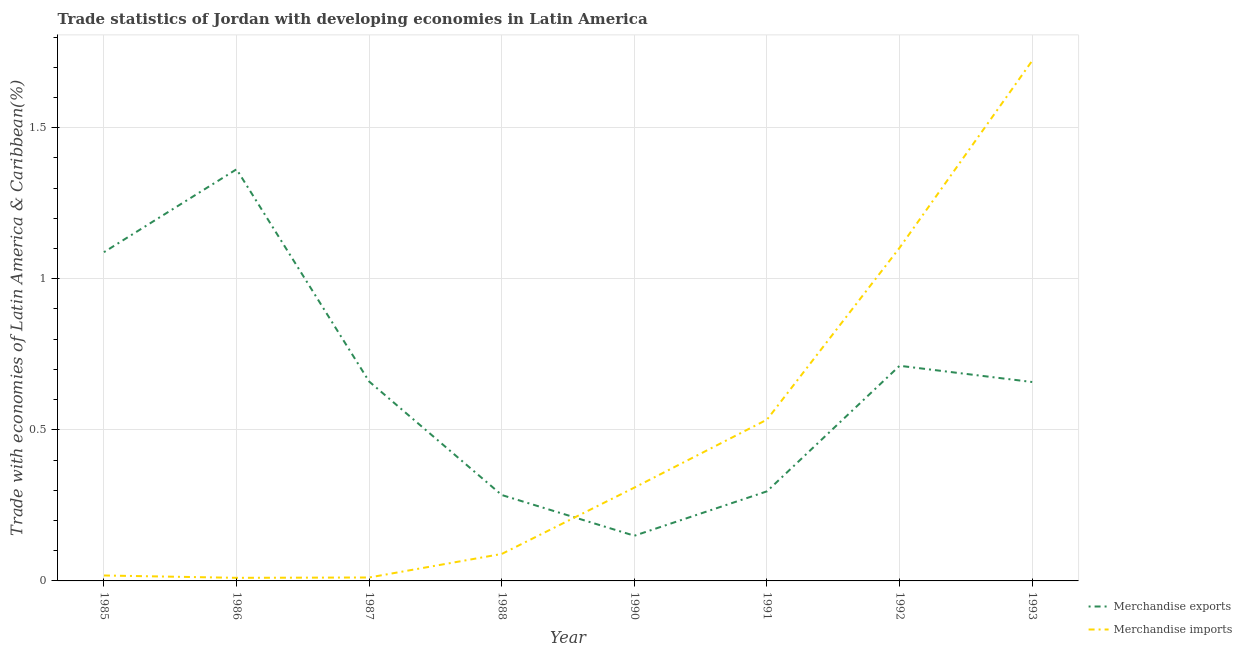How many different coloured lines are there?
Provide a succinct answer. 2. Is the number of lines equal to the number of legend labels?
Your response must be concise. Yes. What is the merchandise imports in 1986?
Your answer should be very brief. 0.01. Across all years, what is the maximum merchandise exports?
Offer a terse response. 1.36. Across all years, what is the minimum merchandise imports?
Your response must be concise. 0.01. In which year was the merchandise exports minimum?
Give a very brief answer. 1990. What is the total merchandise imports in the graph?
Offer a very short reply. 3.8. What is the difference between the merchandise imports in 1991 and that in 1992?
Give a very brief answer. -0.57. What is the difference between the merchandise exports in 1991 and the merchandise imports in 1988?
Give a very brief answer. 0.21. What is the average merchandise imports per year?
Ensure brevity in your answer.  0.47. In the year 1993, what is the difference between the merchandise exports and merchandise imports?
Offer a terse response. -1.06. In how many years, is the merchandise exports greater than 0.4 %?
Offer a terse response. 5. What is the ratio of the merchandise imports in 1987 to that in 1988?
Your answer should be very brief. 0.13. Is the merchandise exports in 1985 less than that in 1991?
Offer a terse response. No. What is the difference between the highest and the second highest merchandise exports?
Your response must be concise. 0.27. What is the difference between the highest and the lowest merchandise imports?
Give a very brief answer. 1.71. Does the merchandise exports monotonically increase over the years?
Provide a succinct answer. No. Is the merchandise imports strictly greater than the merchandise exports over the years?
Your answer should be very brief. No. Is the merchandise imports strictly less than the merchandise exports over the years?
Your answer should be compact. No. How many lines are there?
Your answer should be compact. 2. How many years are there in the graph?
Provide a succinct answer. 8. What is the difference between two consecutive major ticks on the Y-axis?
Ensure brevity in your answer.  0.5. Does the graph contain any zero values?
Your response must be concise. No. Where does the legend appear in the graph?
Ensure brevity in your answer.  Bottom right. How are the legend labels stacked?
Keep it short and to the point. Vertical. What is the title of the graph?
Provide a succinct answer. Trade statistics of Jordan with developing economies in Latin America. What is the label or title of the X-axis?
Your response must be concise. Year. What is the label or title of the Y-axis?
Give a very brief answer. Trade with economies of Latin America & Caribbean(%). What is the Trade with economies of Latin America & Caribbean(%) in Merchandise exports in 1985?
Provide a succinct answer. 1.09. What is the Trade with economies of Latin America & Caribbean(%) in Merchandise imports in 1985?
Your answer should be very brief. 0.02. What is the Trade with economies of Latin America & Caribbean(%) in Merchandise exports in 1986?
Your answer should be very brief. 1.36. What is the Trade with economies of Latin America & Caribbean(%) in Merchandise imports in 1986?
Your response must be concise. 0.01. What is the Trade with economies of Latin America & Caribbean(%) in Merchandise exports in 1987?
Provide a short and direct response. 0.66. What is the Trade with economies of Latin America & Caribbean(%) of Merchandise imports in 1987?
Your answer should be very brief. 0.01. What is the Trade with economies of Latin America & Caribbean(%) of Merchandise exports in 1988?
Provide a short and direct response. 0.28. What is the Trade with economies of Latin America & Caribbean(%) in Merchandise imports in 1988?
Provide a succinct answer. 0.09. What is the Trade with economies of Latin America & Caribbean(%) of Merchandise exports in 1990?
Provide a succinct answer. 0.15. What is the Trade with economies of Latin America & Caribbean(%) in Merchandise imports in 1990?
Your answer should be compact. 0.31. What is the Trade with economies of Latin America & Caribbean(%) of Merchandise exports in 1991?
Offer a terse response. 0.3. What is the Trade with economies of Latin America & Caribbean(%) in Merchandise imports in 1991?
Give a very brief answer. 0.53. What is the Trade with economies of Latin America & Caribbean(%) in Merchandise exports in 1992?
Provide a short and direct response. 0.71. What is the Trade with economies of Latin America & Caribbean(%) in Merchandise imports in 1992?
Your answer should be compact. 1.1. What is the Trade with economies of Latin America & Caribbean(%) in Merchandise exports in 1993?
Your response must be concise. 0.66. What is the Trade with economies of Latin America & Caribbean(%) of Merchandise imports in 1993?
Provide a short and direct response. 1.72. Across all years, what is the maximum Trade with economies of Latin America & Caribbean(%) of Merchandise exports?
Offer a very short reply. 1.36. Across all years, what is the maximum Trade with economies of Latin America & Caribbean(%) in Merchandise imports?
Your response must be concise. 1.72. Across all years, what is the minimum Trade with economies of Latin America & Caribbean(%) of Merchandise exports?
Your answer should be very brief. 0.15. Across all years, what is the minimum Trade with economies of Latin America & Caribbean(%) of Merchandise imports?
Your answer should be compact. 0.01. What is the total Trade with economies of Latin America & Caribbean(%) of Merchandise exports in the graph?
Provide a short and direct response. 5.21. What is the total Trade with economies of Latin America & Caribbean(%) of Merchandise imports in the graph?
Keep it short and to the point. 3.8. What is the difference between the Trade with economies of Latin America & Caribbean(%) of Merchandise exports in 1985 and that in 1986?
Offer a very short reply. -0.27. What is the difference between the Trade with economies of Latin America & Caribbean(%) of Merchandise imports in 1985 and that in 1986?
Your answer should be very brief. 0.01. What is the difference between the Trade with economies of Latin America & Caribbean(%) of Merchandise exports in 1985 and that in 1987?
Your answer should be compact. 0.43. What is the difference between the Trade with economies of Latin America & Caribbean(%) of Merchandise imports in 1985 and that in 1987?
Offer a very short reply. 0.01. What is the difference between the Trade with economies of Latin America & Caribbean(%) of Merchandise exports in 1985 and that in 1988?
Offer a very short reply. 0.8. What is the difference between the Trade with economies of Latin America & Caribbean(%) of Merchandise imports in 1985 and that in 1988?
Your answer should be very brief. -0.07. What is the difference between the Trade with economies of Latin America & Caribbean(%) of Merchandise exports in 1985 and that in 1990?
Offer a very short reply. 0.94. What is the difference between the Trade with economies of Latin America & Caribbean(%) of Merchandise imports in 1985 and that in 1990?
Your answer should be very brief. -0.29. What is the difference between the Trade with economies of Latin America & Caribbean(%) in Merchandise exports in 1985 and that in 1991?
Provide a succinct answer. 0.79. What is the difference between the Trade with economies of Latin America & Caribbean(%) of Merchandise imports in 1985 and that in 1991?
Your answer should be very brief. -0.52. What is the difference between the Trade with economies of Latin America & Caribbean(%) of Merchandise exports in 1985 and that in 1992?
Ensure brevity in your answer.  0.38. What is the difference between the Trade with economies of Latin America & Caribbean(%) of Merchandise imports in 1985 and that in 1992?
Ensure brevity in your answer.  -1.08. What is the difference between the Trade with economies of Latin America & Caribbean(%) in Merchandise exports in 1985 and that in 1993?
Ensure brevity in your answer.  0.43. What is the difference between the Trade with economies of Latin America & Caribbean(%) in Merchandise imports in 1985 and that in 1993?
Offer a terse response. -1.7. What is the difference between the Trade with economies of Latin America & Caribbean(%) of Merchandise exports in 1986 and that in 1987?
Your answer should be compact. 0.7. What is the difference between the Trade with economies of Latin America & Caribbean(%) of Merchandise imports in 1986 and that in 1987?
Offer a very short reply. -0. What is the difference between the Trade with economies of Latin America & Caribbean(%) of Merchandise exports in 1986 and that in 1988?
Provide a succinct answer. 1.08. What is the difference between the Trade with economies of Latin America & Caribbean(%) of Merchandise imports in 1986 and that in 1988?
Your answer should be very brief. -0.08. What is the difference between the Trade with economies of Latin America & Caribbean(%) of Merchandise exports in 1986 and that in 1990?
Your answer should be compact. 1.21. What is the difference between the Trade with economies of Latin America & Caribbean(%) of Merchandise imports in 1986 and that in 1990?
Offer a terse response. -0.3. What is the difference between the Trade with economies of Latin America & Caribbean(%) in Merchandise exports in 1986 and that in 1991?
Provide a short and direct response. 1.07. What is the difference between the Trade with economies of Latin America & Caribbean(%) of Merchandise imports in 1986 and that in 1991?
Provide a succinct answer. -0.52. What is the difference between the Trade with economies of Latin America & Caribbean(%) in Merchandise exports in 1986 and that in 1992?
Offer a terse response. 0.65. What is the difference between the Trade with economies of Latin America & Caribbean(%) in Merchandise imports in 1986 and that in 1992?
Your answer should be compact. -1.09. What is the difference between the Trade with economies of Latin America & Caribbean(%) of Merchandise exports in 1986 and that in 1993?
Keep it short and to the point. 0.7. What is the difference between the Trade with economies of Latin America & Caribbean(%) in Merchandise imports in 1986 and that in 1993?
Offer a terse response. -1.71. What is the difference between the Trade with economies of Latin America & Caribbean(%) in Merchandise exports in 1987 and that in 1988?
Make the answer very short. 0.38. What is the difference between the Trade with economies of Latin America & Caribbean(%) of Merchandise imports in 1987 and that in 1988?
Offer a terse response. -0.08. What is the difference between the Trade with economies of Latin America & Caribbean(%) of Merchandise exports in 1987 and that in 1990?
Offer a terse response. 0.51. What is the difference between the Trade with economies of Latin America & Caribbean(%) of Merchandise imports in 1987 and that in 1990?
Provide a succinct answer. -0.3. What is the difference between the Trade with economies of Latin America & Caribbean(%) of Merchandise exports in 1987 and that in 1991?
Your response must be concise. 0.36. What is the difference between the Trade with economies of Latin America & Caribbean(%) of Merchandise imports in 1987 and that in 1991?
Make the answer very short. -0.52. What is the difference between the Trade with economies of Latin America & Caribbean(%) in Merchandise exports in 1987 and that in 1992?
Provide a succinct answer. -0.05. What is the difference between the Trade with economies of Latin America & Caribbean(%) of Merchandise imports in 1987 and that in 1992?
Your response must be concise. -1.09. What is the difference between the Trade with economies of Latin America & Caribbean(%) of Merchandise exports in 1987 and that in 1993?
Offer a very short reply. 0. What is the difference between the Trade with economies of Latin America & Caribbean(%) of Merchandise imports in 1987 and that in 1993?
Keep it short and to the point. -1.71. What is the difference between the Trade with economies of Latin America & Caribbean(%) in Merchandise exports in 1988 and that in 1990?
Make the answer very short. 0.13. What is the difference between the Trade with economies of Latin America & Caribbean(%) of Merchandise imports in 1988 and that in 1990?
Keep it short and to the point. -0.22. What is the difference between the Trade with economies of Latin America & Caribbean(%) in Merchandise exports in 1988 and that in 1991?
Your answer should be very brief. -0.01. What is the difference between the Trade with economies of Latin America & Caribbean(%) in Merchandise imports in 1988 and that in 1991?
Your response must be concise. -0.44. What is the difference between the Trade with economies of Latin America & Caribbean(%) in Merchandise exports in 1988 and that in 1992?
Provide a succinct answer. -0.43. What is the difference between the Trade with economies of Latin America & Caribbean(%) in Merchandise imports in 1988 and that in 1992?
Provide a succinct answer. -1.01. What is the difference between the Trade with economies of Latin America & Caribbean(%) of Merchandise exports in 1988 and that in 1993?
Offer a terse response. -0.37. What is the difference between the Trade with economies of Latin America & Caribbean(%) of Merchandise imports in 1988 and that in 1993?
Provide a succinct answer. -1.63. What is the difference between the Trade with economies of Latin America & Caribbean(%) in Merchandise exports in 1990 and that in 1991?
Provide a short and direct response. -0.15. What is the difference between the Trade with economies of Latin America & Caribbean(%) of Merchandise imports in 1990 and that in 1991?
Ensure brevity in your answer.  -0.22. What is the difference between the Trade with economies of Latin America & Caribbean(%) in Merchandise exports in 1990 and that in 1992?
Offer a terse response. -0.56. What is the difference between the Trade with economies of Latin America & Caribbean(%) in Merchandise imports in 1990 and that in 1992?
Offer a terse response. -0.79. What is the difference between the Trade with economies of Latin America & Caribbean(%) in Merchandise exports in 1990 and that in 1993?
Provide a succinct answer. -0.51. What is the difference between the Trade with economies of Latin America & Caribbean(%) of Merchandise imports in 1990 and that in 1993?
Offer a terse response. -1.41. What is the difference between the Trade with economies of Latin America & Caribbean(%) in Merchandise exports in 1991 and that in 1992?
Your answer should be very brief. -0.42. What is the difference between the Trade with economies of Latin America & Caribbean(%) in Merchandise imports in 1991 and that in 1992?
Offer a terse response. -0.57. What is the difference between the Trade with economies of Latin America & Caribbean(%) of Merchandise exports in 1991 and that in 1993?
Make the answer very short. -0.36. What is the difference between the Trade with economies of Latin America & Caribbean(%) in Merchandise imports in 1991 and that in 1993?
Your answer should be very brief. -1.19. What is the difference between the Trade with economies of Latin America & Caribbean(%) of Merchandise exports in 1992 and that in 1993?
Give a very brief answer. 0.05. What is the difference between the Trade with economies of Latin America & Caribbean(%) in Merchandise imports in 1992 and that in 1993?
Ensure brevity in your answer.  -0.62. What is the difference between the Trade with economies of Latin America & Caribbean(%) in Merchandise exports in 1985 and the Trade with economies of Latin America & Caribbean(%) in Merchandise imports in 1986?
Your answer should be compact. 1.08. What is the difference between the Trade with economies of Latin America & Caribbean(%) in Merchandise exports in 1985 and the Trade with economies of Latin America & Caribbean(%) in Merchandise imports in 1987?
Offer a very short reply. 1.08. What is the difference between the Trade with economies of Latin America & Caribbean(%) of Merchandise exports in 1985 and the Trade with economies of Latin America & Caribbean(%) of Merchandise imports in 1988?
Your answer should be very brief. 1. What is the difference between the Trade with economies of Latin America & Caribbean(%) in Merchandise exports in 1985 and the Trade with economies of Latin America & Caribbean(%) in Merchandise imports in 1990?
Offer a very short reply. 0.78. What is the difference between the Trade with economies of Latin America & Caribbean(%) in Merchandise exports in 1985 and the Trade with economies of Latin America & Caribbean(%) in Merchandise imports in 1991?
Your response must be concise. 0.55. What is the difference between the Trade with economies of Latin America & Caribbean(%) in Merchandise exports in 1985 and the Trade with economies of Latin America & Caribbean(%) in Merchandise imports in 1992?
Ensure brevity in your answer.  -0.01. What is the difference between the Trade with economies of Latin America & Caribbean(%) in Merchandise exports in 1985 and the Trade with economies of Latin America & Caribbean(%) in Merchandise imports in 1993?
Offer a very short reply. -0.63. What is the difference between the Trade with economies of Latin America & Caribbean(%) in Merchandise exports in 1986 and the Trade with economies of Latin America & Caribbean(%) in Merchandise imports in 1987?
Offer a terse response. 1.35. What is the difference between the Trade with economies of Latin America & Caribbean(%) of Merchandise exports in 1986 and the Trade with economies of Latin America & Caribbean(%) of Merchandise imports in 1988?
Your answer should be very brief. 1.27. What is the difference between the Trade with economies of Latin America & Caribbean(%) in Merchandise exports in 1986 and the Trade with economies of Latin America & Caribbean(%) in Merchandise imports in 1990?
Provide a short and direct response. 1.05. What is the difference between the Trade with economies of Latin America & Caribbean(%) of Merchandise exports in 1986 and the Trade with economies of Latin America & Caribbean(%) of Merchandise imports in 1991?
Offer a terse response. 0.83. What is the difference between the Trade with economies of Latin America & Caribbean(%) in Merchandise exports in 1986 and the Trade with economies of Latin America & Caribbean(%) in Merchandise imports in 1992?
Ensure brevity in your answer.  0.26. What is the difference between the Trade with economies of Latin America & Caribbean(%) of Merchandise exports in 1986 and the Trade with economies of Latin America & Caribbean(%) of Merchandise imports in 1993?
Give a very brief answer. -0.36. What is the difference between the Trade with economies of Latin America & Caribbean(%) in Merchandise exports in 1987 and the Trade with economies of Latin America & Caribbean(%) in Merchandise imports in 1988?
Offer a very short reply. 0.57. What is the difference between the Trade with economies of Latin America & Caribbean(%) of Merchandise exports in 1987 and the Trade with economies of Latin America & Caribbean(%) of Merchandise imports in 1990?
Provide a succinct answer. 0.35. What is the difference between the Trade with economies of Latin America & Caribbean(%) in Merchandise exports in 1987 and the Trade with economies of Latin America & Caribbean(%) in Merchandise imports in 1991?
Keep it short and to the point. 0.13. What is the difference between the Trade with economies of Latin America & Caribbean(%) of Merchandise exports in 1987 and the Trade with economies of Latin America & Caribbean(%) of Merchandise imports in 1992?
Your response must be concise. -0.44. What is the difference between the Trade with economies of Latin America & Caribbean(%) of Merchandise exports in 1987 and the Trade with economies of Latin America & Caribbean(%) of Merchandise imports in 1993?
Give a very brief answer. -1.06. What is the difference between the Trade with economies of Latin America & Caribbean(%) of Merchandise exports in 1988 and the Trade with economies of Latin America & Caribbean(%) of Merchandise imports in 1990?
Your response must be concise. -0.02. What is the difference between the Trade with economies of Latin America & Caribbean(%) of Merchandise exports in 1988 and the Trade with economies of Latin America & Caribbean(%) of Merchandise imports in 1991?
Your answer should be very brief. -0.25. What is the difference between the Trade with economies of Latin America & Caribbean(%) in Merchandise exports in 1988 and the Trade with economies of Latin America & Caribbean(%) in Merchandise imports in 1992?
Ensure brevity in your answer.  -0.82. What is the difference between the Trade with economies of Latin America & Caribbean(%) in Merchandise exports in 1988 and the Trade with economies of Latin America & Caribbean(%) in Merchandise imports in 1993?
Offer a terse response. -1.44. What is the difference between the Trade with economies of Latin America & Caribbean(%) of Merchandise exports in 1990 and the Trade with economies of Latin America & Caribbean(%) of Merchandise imports in 1991?
Your answer should be very brief. -0.38. What is the difference between the Trade with economies of Latin America & Caribbean(%) of Merchandise exports in 1990 and the Trade with economies of Latin America & Caribbean(%) of Merchandise imports in 1992?
Offer a very short reply. -0.95. What is the difference between the Trade with economies of Latin America & Caribbean(%) of Merchandise exports in 1990 and the Trade with economies of Latin America & Caribbean(%) of Merchandise imports in 1993?
Keep it short and to the point. -1.57. What is the difference between the Trade with economies of Latin America & Caribbean(%) of Merchandise exports in 1991 and the Trade with economies of Latin America & Caribbean(%) of Merchandise imports in 1992?
Ensure brevity in your answer.  -0.81. What is the difference between the Trade with economies of Latin America & Caribbean(%) in Merchandise exports in 1991 and the Trade with economies of Latin America & Caribbean(%) in Merchandise imports in 1993?
Make the answer very short. -1.43. What is the difference between the Trade with economies of Latin America & Caribbean(%) of Merchandise exports in 1992 and the Trade with economies of Latin America & Caribbean(%) of Merchandise imports in 1993?
Your answer should be compact. -1.01. What is the average Trade with economies of Latin America & Caribbean(%) in Merchandise exports per year?
Provide a short and direct response. 0.65. What is the average Trade with economies of Latin America & Caribbean(%) of Merchandise imports per year?
Provide a short and direct response. 0.47. In the year 1985, what is the difference between the Trade with economies of Latin America & Caribbean(%) in Merchandise exports and Trade with economies of Latin America & Caribbean(%) in Merchandise imports?
Offer a very short reply. 1.07. In the year 1986, what is the difference between the Trade with economies of Latin America & Caribbean(%) of Merchandise exports and Trade with economies of Latin America & Caribbean(%) of Merchandise imports?
Your answer should be very brief. 1.35. In the year 1987, what is the difference between the Trade with economies of Latin America & Caribbean(%) in Merchandise exports and Trade with economies of Latin America & Caribbean(%) in Merchandise imports?
Keep it short and to the point. 0.65. In the year 1988, what is the difference between the Trade with economies of Latin America & Caribbean(%) in Merchandise exports and Trade with economies of Latin America & Caribbean(%) in Merchandise imports?
Keep it short and to the point. 0.2. In the year 1990, what is the difference between the Trade with economies of Latin America & Caribbean(%) of Merchandise exports and Trade with economies of Latin America & Caribbean(%) of Merchandise imports?
Your answer should be very brief. -0.16. In the year 1991, what is the difference between the Trade with economies of Latin America & Caribbean(%) of Merchandise exports and Trade with economies of Latin America & Caribbean(%) of Merchandise imports?
Your response must be concise. -0.24. In the year 1992, what is the difference between the Trade with economies of Latin America & Caribbean(%) in Merchandise exports and Trade with economies of Latin America & Caribbean(%) in Merchandise imports?
Ensure brevity in your answer.  -0.39. In the year 1993, what is the difference between the Trade with economies of Latin America & Caribbean(%) of Merchandise exports and Trade with economies of Latin America & Caribbean(%) of Merchandise imports?
Provide a short and direct response. -1.06. What is the ratio of the Trade with economies of Latin America & Caribbean(%) in Merchandise exports in 1985 to that in 1986?
Make the answer very short. 0.8. What is the ratio of the Trade with economies of Latin America & Caribbean(%) in Merchandise imports in 1985 to that in 1986?
Your answer should be compact. 1.76. What is the ratio of the Trade with economies of Latin America & Caribbean(%) in Merchandise exports in 1985 to that in 1987?
Your answer should be compact. 1.65. What is the ratio of the Trade with economies of Latin America & Caribbean(%) of Merchandise imports in 1985 to that in 1987?
Give a very brief answer. 1.58. What is the ratio of the Trade with economies of Latin America & Caribbean(%) of Merchandise exports in 1985 to that in 1988?
Your answer should be compact. 3.83. What is the ratio of the Trade with economies of Latin America & Caribbean(%) in Merchandise imports in 1985 to that in 1988?
Your answer should be compact. 0.2. What is the ratio of the Trade with economies of Latin America & Caribbean(%) in Merchandise exports in 1985 to that in 1990?
Your response must be concise. 7.27. What is the ratio of the Trade with economies of Latin America & Caribbean(%) of Merchandise imports in 1985 to that in 1990?
Your answer should be very brief. 0.06. What is the ratio of the Trade with economies of Latin America & Caribbean(%) of Merchandise exports in 1985 to that in 1991?
Offer a terse response. 3.67. What is the ratio of the Trade with economies of Latin America & Caribbean(%) in Merchandise imports in 1985 to that in 1991?
Make the answer very short. 0.03. What is the ratio of the Trade with economies of Latin America & Caribbean(%) of Merchandise exports in 1985 to that in 1992?
Make the answer very short. 1.53. What is the ratio of the Trade with economies of Latin America & Caribbean(%) in Merchandise imports in 1985 to that in 1992?
Offer a terse response. 0.02. What is the ratio of the Trade with economies of Latin America & Caribbean(%) of Merchandise exports in 1985 to that in 1993?
Keep it short and to the point. 1.65. What is the ratio of the Trade with economies of Latin America & Caribbean(%) of Merchandise imports in 1985 to that in 1993?
Ensure brevity in your answer.  0.01. What is the ratio of the Trade with economies of Latin America & Caribbean(%) in Merchandise exports in 1986 to that in 1987?
Your answer should be very brief. 2.06. What is the ratio of the Trade with economies of Latin America & Caribbean(%) of Merchandise imports in 1986 to that in 1987?
Provide a succinct answer. 0.9. What is the ratio of the Trade with economies of Latin America & Caribbean(%) of Merchandise exports in 1986 to that in 1988?
Your answer should be compact. 4.79. What is the ratio of the Trade with economies of Latin America & Caribbean(%) in Merchandise imports in 1986 to that in 1988?
Keep it short and to the point. 0.11. What is the ratio of the Trade with economies of Latin America & Caribbean(%) of Merchandise exports in 1986 to that in 1990?
Your answer should be compact. 9.11. What is the ratio of the Trade with economies of Latin America & Caribbean(%) of Merchandise imports in 1986 to that in 1990?
Give a very brief answer. 0.03. What is the ratio of the Trade with economies of Latin America & Caribbean(%) in Merchandise exports in 1986 to that in 1991?
Offer a very short reply. 4.6. What is the ratio of the Trade with economies of Latin America & Caribbean(%) in Merchandise imports in 1986 to that in 1991?
Provide a succinct answer. 0.02. What is the ratio of the Trade with economies of Latin America & Caribbean(%) of Merchandise exports in 1986 to that in 1992?
Offer a terse response. 1.91. What is the ratio of the Trade with economies of Latin America & Caribbean(%) in Merchandise imports in 1986 to that in 1992?
Keep it short and to the point. 0.01. What is the ratio of the Trade with economies of Latin America & Caribbean(%) of Merchandise exports in 1986 to that in 1993?
Ensure brevity in your answer.  2.07. What is the ratio of the Trade with economies of Latin America & Caribbean(%) in Merchandise imports in 1986 to that in 1993?
Keep it short and to the point. 0.01. What is the ratio of the Trade with economies of Latin America & Caribbean(%) in Merchandise exports in 1987 to that in 1988?
Make the answer very short. 2.32. What is the ratio of the Trade with economies of Latin America & Caribbean(%) of Merchandise imports in 1987 to that in 1988?
Provide a succinct answer. 0.13. What is the ratio of the Trade with economies of Latin America & Caribbean(%) in Merchandise exports in 1987 to that in 1990?
Keep it short and to the point. 4.41. What is the ratio of the Trade with economies of Latin America & Caribbean(%) in Merchandise imports in 1987 to that in 1990?
Your answer should be very brief. 0.04. What is the ratio of the Trade with economies of Latin America & Caribbean(%) of Merchandise exports in 1987 to that in 1991?
Your answer should be very brief. 2.23. What is the ratio of the Trade with economies of Latin America & Caribbean(%) in Merchandise imports in 1987 to that in 1991?
Give a very brief answer. 0.02. What is the ratio of the Trade with economies of Latin America & Caribbean(%) of Merchandise exports in 1987 to that in 1992?
Provide a short and direct response. 0.93. What is the ratio of the Trade with economies of Latin America & Caribbean(%) of Merchandise imports in 1987 to that in 1992?
Ensure brevity in your answer.  0.01. What is the ratio of the Trade with economies of Latin America & Caribbean(%) in Merchandise imports in 1987 to that in 1993?
Your answer should be compact. 0.01. What is the ratio of the Trade with economies of Latin America & Caribbean(%) in Merchandise exports in 1988 to that in 1990?
Your answer should be very brief. 1.9. What is the ratio of the Trade with economies of Latin America & Caribbean(%) of Merchandise imports in 1988 to that in 1990?
Give a very brief answer. 0.29. What is the ratio of the Trade with economies of Latin America & Caribbean(%) in Merchandise exports in 1988 to that in 1991?
Your answer should be compact. 0.96. What is the ratio of the Trade with economies of Latin America & Caribbean(%) in Merchandise imports in 1988 to that in 1991?
Your response must be concise. 0.17. What is the ratio of the Trade with economies of Latin America & Caribbean(%) in Merchandise exports in 1988 to that in 1992?
Keep it short and to the point. 0.4. What is the ratio of the Trade with economies of Latin America & Caribbean(%) in Merchandise imports in 1988 to that in 1992?
Offer a terse response. 0.08. What is the ratio of the Trade with economies of Latin America & Caribbean(%) in Merchandise exports in 1988 to that in 1993?
Your answer should be very brief. 0.43. What is the ratio of the Trade with economies of Latin America & Caribbean(%) of Merchandise imports in 1988 to that in 1993?
Make the answer very short. 0.05. What is the ratio of the Trade with economies of Latin America & Caribbean(%) of Merchandise exports in 1990 to that in 1991?
Offer a terse response. 0.5. What is the ratio of the Trade with economies of Latin America & Caribbean(%) in Merchandise imports in 1990 to that in 1991?
Give a very brief answer. 0.58. What is the ratio of the Trade with economies of Latin America & Caribbean(%) of Merchandise exports in 1990 to that in 1992?
Your response must be concise. 0.21. What is the ratio of the Trade with economies of Latin America & Caribbean(%) in Merchandise imports in 1990 to that in 1992?
Keep it short and to the point. 0.28. What is the ratio of the Trade with economies of Latin America & Caribbean(%) of Merchandise exports in 1990 to that in 1993?
Offer a terse response. 0.23. What is the ratio of the Trade with economies of Latin America & Caribbean(%) in Merchandise imports in 1990 to that in 1993?
Make the answer very short. 0.18. What is the ratio of the Trade with economies of Latin America & Caribbean(%) in Merchandise exports in 1991 to that in 1992?
Your response must be concise. 0.42. What is the ratio of the Trade with economies of Latin America & Caribbean(%) in Merchandise imports in 1991 to that in 1992?
Provide a succinct answer. 0.48. What is the ratio of the Trade with economies of Latin America & Caribbean(%) in Merchandise exports in 1991 to that in 1993?
Your answer should be compact. 0.45. What is the ratio of the Trade with economies of Latin America & Caribbean(%) in Merchandise imports in 1991 to that in 1993?
Make the answer very short. 0.31. What is the ratio of the Trade with economies of Latin America & Caribbean(%) in Merchandise exports in 1992 to that in 1993?
Provide a succinct answer. 1.08. What is the ratio of the Trade with economies of Latin America & Caribbean(%) of Merchandise imports in 1992 to that in 1993?
Your response must be concise. 0.64. What is the difference between the highest and the second highest Trade with economies of Latin America & Caribbean(%) of Merchandise exports?
Offer a very short reply. 0.27. What is the difference between the highest and the second highest Trade with economies of Latin America & Caribbean(%) in Merchandise imports?
Your answer should be very brief. 0.62. What is the difference between the highest and the lowest Trade with economies of Latin America & Caribbean(%) in Merchandise exports?
Offer a terse response. 1.21. What is the difference between the highest and the lowest Trade with economies of Latin America & Caribbean(%) in Merchandise imports?
Ensure brevity in your answer.  1.71. 